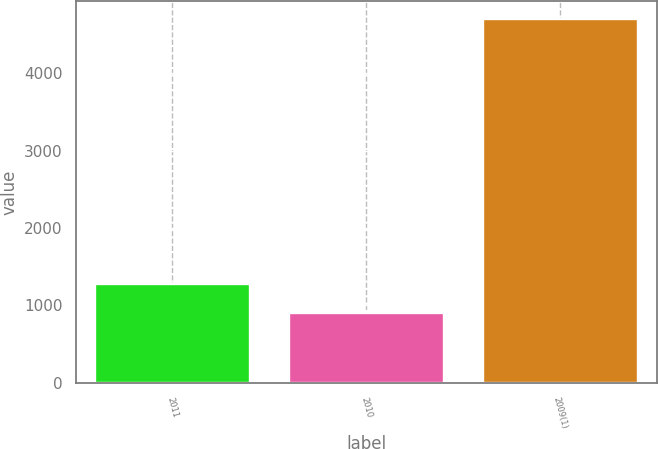Convert chart. <chart><loc_0><loc_0><loc_500><loc_500><bar_chart><fcel>2011<fcel>2010<fcel>2009(1)<nl><fcel>1278.9<fcel>899<fcel>4698<nl></chart> 